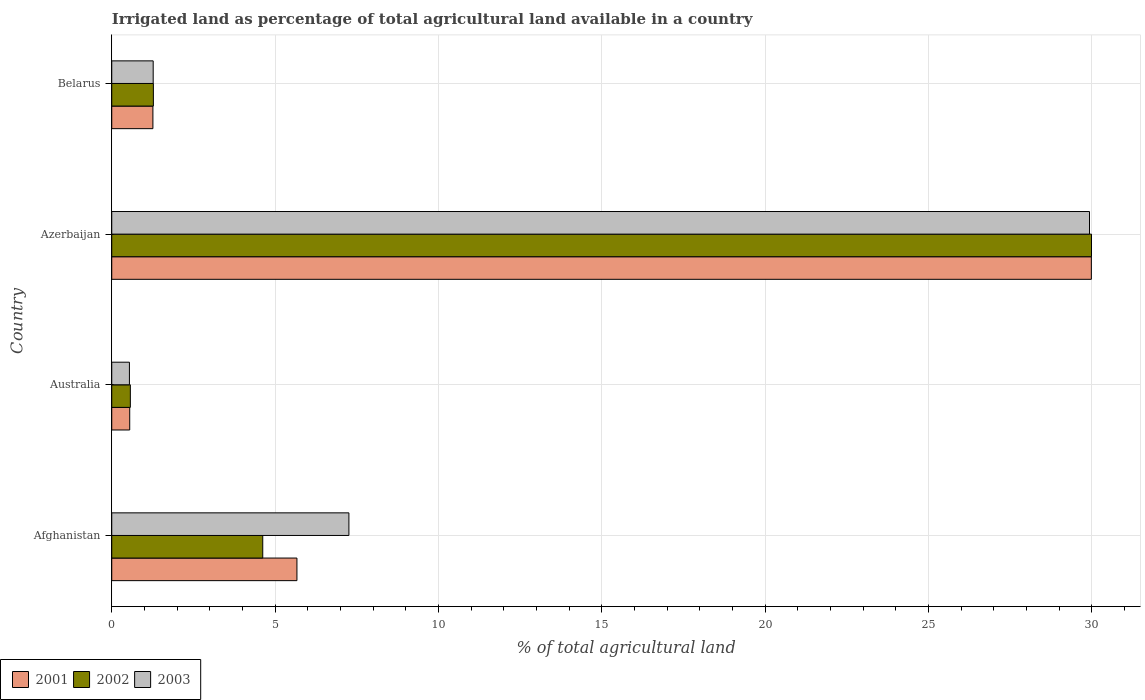How many bars are there on the 2nd tick from the bottom?
Provide a succinct answer. 3. What is the label of the 4th group of bars from the top?
Give a very brief answer. Afghanistan. In how many cases, is the number of bars for a given country not equal to the number of legend labels?
Your answer should be compact. 0. What is the percentage of irrigated land in 2001 in Azerbaijan?
Ensure brevity in your answer.  29.99. Across all countries, what is the maximum percentage of irrigated land in 2001?
Make the answer very short. 29.99. Across all countries, what is the minimum percentage of irrigated land in 2003?
Provide a short and direct response. 0.54. In which country was the percentage of irrigated land in 2003 maximum?
Provide a succinct answer. Azerbaijan. In which country was the percentage of irrigated land in 2003 minimum?
Your answer should be very brief. Australia. What is the total percentage of irrigated land in 2001 in the graph?
Make the answer very short. 37.46. What is the difference between the percentage of irrigated land in 2003 in Azerbaijan and that in Belarus?
Ensure brevity in your answer.  28.66. What is the difference between the percentage of irrigated land in 2003 in Afghanistan and the percentage of irrigated land in 2001 in Australia?
Keep it short and to the point. 6.71. What is the average percentage of irrigated land in 2001 per country?
Your answer should be very brief. 9.37. What is the difference between the percentage of irrigated land in 2001 and percentage of irrigated land in 2003 in Azerbaijan?
Your answer should be very brief. 0.06. In how many countries, is the percentage of irrigated land in 2002 greater than 2 %?
Offer a terse response. 2. What is the ratio of the percentage of irrigated land in 2002 in Australia to that in Azerbaijan?
Give a very brief answer. 0.02. Is the difference between the percentage of irrigated land in 2001 in Afghanistan and Australia greater than the difference between the percentage of irrigated land in 2003 in Afghanistan and Australia?
Your response must be concise. No. What is the difference between the highest and the second highest percentage of irrigated land in 2001?
Your response must be concise. 24.32. What is the difference between the highest and the lowest percentage of irrigated land in 2001?
Keep it short and to the point. 29.44. Is the sum of the percentage of irrigated land in 2002 in Azerbaijan and Belarus greater than the maximum percentage of irrigated land in 2003 across all countries?
Provide a short and direct response. Yes. What does the 3rd bar from the bottom in Australia represents?
Give a very brief answer. 2003. Are all the bars in the graph horizontal?
Offer a very short reply. Yes. What is the difference between two consecutive major ticks on the X-axis?
Offer a very short reply. 5. Are the values on the major ticks of X-axis written in scientific E-notation?
Keep it short and to the point. No. How many legend labels are there?
Offer a terse response. 3. How are the legend labels stacked?
Your response must be concise. Horizontal. What is the title of the graph?
Offer a very short reply. Irrigated land as percentage of total agricultural land available in a country. What is the label or title of the X-axis?
Your answer should be compact. % of total agricultural land. What is the % of total agricultural land of 2001 in Afghanistan?
Offer a very short reply. 5.67. What is the % of total agricultural land in 2002 in Afghanistan?
Provide a succinct answer. 4.62. What is the % of total agricultural land in 2003 in Afghanistan?
Offer a terse response. 7.26. What is the % of total agricultural land in 2001 in Australia?
Your response must be concise. 0.55. What is the % of total agricultural land of 2002 in Australia?
Provide a succinct answer. 0.57. What is the % of total agricultural land in 2003 in Australia?
Ensure brevity in your answer.  0.54. What is the % of total agricultural land of 2001 in Azerbaijan?
Offer a very short reply. 29.99. What is the % of total agricultural land in 2002 in Azerbaijan?
Offer a terse response. 29.99. What is the % of total agricultural land in 2003 in Azerbaijan?
Make the answer very short. 29.93. What is the % of total agricultural land of 2001 in Belarus?
Provide a succinct answer. 1.26. What is the % of total agricultural land in 2002 in Belarus?
Your response must be concise. 1.27. What is the % of total agricultural land of 2003 in Belarus?
Give a very brief answer. 1.27. Across all countries, what is the maximum % of total agricultural land of 2001?
Offer a terse response. 29.99. Across all countries, what is the maximum % of total agricultural land in 2002?
Your answer should be very brief. 29.99. Across all countries, what is the maximum % of total agricultural land in 2003?
Ensure brevity in your answer.  29.93. Across all countries, what is the minimum % of total agricultural land of 2001?
Give a very brief answer. 0.55. Across all countries, what is the minimum % of total agricultural land of 2002?
Give a very brief answer. 0.57. Across all countries, what is the minimum % of total agricultural land of 2003?
Your answer should be very brief. 0.54. What is the total % of total agricultural land of 2001 in the graph?
Give a very brief answer. 37.46. What is the total % of total agricultural land of 2002 in the graph?
Offer a terse response. 36.46. What is the total % of total agricultural land of 2003 in the graph?
Your response must be concise. 39. What is the difference between the % of total agricultural land of 2001 in Afghanistan and that in Australia?
Your answer should be compact. 5.12. What is the difference between the % of total agricultural land in 2002 in Afghanistan and that in Australia?
Give a very brief answer. 4.05. What is the difference between the % of total agricultural land in 2003 in Afghanistan and that in Australia?
Give a very brief answer. 6.72. What is the difference between the % of total agricultural land of 2001 in Afghanistan and that in Azerbaijan?
Keep it short and to the point. -24.32. What is the difference between the % of total agricultural land in 2002 in Afghanistan and that in Azerbaijan?
Offer a terse response. -25.37. What is the difference between the % of total agricultural land in 2003 in Afghanistan and that in Azerbaijan?
Provide a short and direct response. -22.67. What is the difference between the % of total agricultural land in 2001 in Afghanistan and that in Belarus?
Offer a very short reply. 4.41. What is the difference between the % of total agricultural land in 2002 in Afghanistan and that in Belarus?
Keep it short and to the point. 3.35. What is the difference between the % of total agricultural land of 2003 in Afghanistan and that in Belarus?
Keep it short and to the point. 5.99. What is the difference between the % of total agricultural land of 2001 in Australia and that in Azerbaijan?
Your answer should be very brief. -29.44. What is the difference between the % of total agricultural land in 2002 in Australia and that in Azerbaijan?
Make the answer very short. -29.42. What is the difference between the % of total agricultural land in 2003 in Australia and that in Azerbaijan?
Your answer should be compact. -29.39. What is the difference between the % of total agricultural land in 2001 in Australia and that in Belarus?
Provide a succinct answer. -0.71. What is the difference between the % of total agricultural land of 2002 in Australia and that in Belarus?
Keep it short and to the point. -0.7. What is the difference between the % of total agricultural land in 2003 in Australia and that in Belarus?
Keep it short and to the point. -0.73. What is the difference between the % of total agricultural land of 2001 in Azerbaijan and that in Belarus?
Make the answer very short. 28.73. What is the difference between the % of total agricultural land of 2002 in Azerbaijan and that in Belarus?
Offer a terse response. 28.72. What is the difference between the % of total agricultural land in 2003 in Azerbaijan and that in Belarus?
Offer a terse response. 28.66. What is the difference between the % of total agricultural land of 2001 in Afghanistan and the % of total agricultural land of 2002 in Australia?
Keep it short and to the point. 5.1. What is the difference between the % of total agricultural land in 2001 in Afghanistan and the % of total agricultural land in 2003 in Australia?
Give a very brief answer. 5.13. What is the difference between the % of total agricultural land of 2002 in Afghanistan and the % of total agricultural land of 2003 in Australia?
Provide a short and direct response. 4.08. What is the difference between the % of total agricultural land in 2001 in Afghanistan and the % of total agricultural land in 2002 in Azerbaijan?
Offer a very short reply. -24.32. What is the difference between the % of total agricultural land of 2001 in Afghanistan and the % of total agricultural land of 2003 in Azerbaijan?
Your response must be concise. -24.26. What is the difference between the % of total agricultural land in 2002 in Afghanistan and the % of total agricultural land in 2003 in Azerbaijan?
Your response must be concise. -25.31. What is the difference between the % of total agricultural land of 2001 in Afghanistan and the % of total agricultural land of 2002 in Belarus?
Keep it short and to the point. 4.39. What is the difference between the % of total agricultural land of 2001 in Afghanistan and the % of total agricultural land of 2003 in Belarus?
Offer a terse response. 4.4. What is the difference between the % of total agricultural land in 2002 in Afghanistan and the % of total agricultural land in 2003 in Belarus?
Keep it short and to the point. 3.35. What is the difference between the % of total agricultural land in 2001 in Australia and the % of total agricultural land in 2002 in Azerbaijan?
Provide a succinct answer. -29.44. What is the difference between the % of total agricultural land in 2001 in Australia and the % of total agricultural land in 2003 in Azerbaijan?
Offer a terse response. -29.38. What is the difference between the % of total agricultural land of 2002 in Australia and the % of total agricultural land of 2003 in Azerbaijan?
Keep it short and to the point. -29.36. What is the difference between the % of total agricultural land of 2001 in Australia and the % of total agricultural land of 2002 in Belarus?
Your answer should be compact. -0.72. What is the difference between the % of total agricultural land of 2001 in Australia and the % of total agricultural land of 2003 in Belarus?
Offer a very short reply. -0.72. What is the difference between the % of total agricultural land of 2002 in Australia and the % of total agricultural land of 2003 in Belarus?
Your response must be concise. -0.7. What is the difference between the % of total agricultural land in 2001 in Azerbaijan and the % of total agricultural land in 2002 in Belarus?
Your response must be concise. 28.71. What is the difference between the % of total agricultural land of 2001 in Azerbaijan and the % of total agricultural land of 2003 in Belarus?
Provide a succinct answer. 28.72. What is the difference between the % of total agricultural land of 2002 in Azerbaijan and the % of total agricultural land of 2003 in Belarus?
Your answer should be compact. 28.72. What is the average % of total agricultural land of 2001 per country?
Offer a terse response. 9.37. What is the average % of total agricultural land in 2002 per country?
Provide a succinct answer. 9.11. What is the average % of total agricultural land in 2003 per country?
Your answer should be compact. 9.75. What is the difference between the % of total agricultural land in 2001 and % of total agricultural land in 2002 in Afghanistan?
Your response must be concise. 1.05. What is the difference between the % of total agricultural land of 2001 and % of total agricultural land of 2003 in Afghanistan?
Keep it short and to the point. -1.59. What is the difference between the % of total agricultural land in 2002 and % of total agricultural land in 2003 in Afghanistan?
Your answer should be compact. -2.64. What is the difference between the % of total agricultural land in 2001 and % of total agricultural land in 2002 in Australia?
Ensure brevity in your answer.  -0.02. What is the difference between the % of total agricultural land in 2001 and % of total agricultural land in 2003 in Australia?
Offer a terse response. 0.01. What is the difference between the % of total agricultural land of 2002 and % of total agricultural land of 2003 in Australia?
Your answer should be very brief. 0.03. What is the difference between the % of total agricultural land of 2001 and % of total agricultural land of 2002 in Azerbaijan?
Give a very brief answer. -0. What is the difference between the % of total agricultural land in 2001 and % of total agricultural land in 2003 in Azerbaijan?
Keep it short and to the point. 0.06. What is the difference between the % of total agricultural land in 2002 and % of total agricultural land in 2003 in Azerbaijan?
Give a very brief answer. 0.06. What is the difference between the % of total agricultural land in 2001 and % of total agricultural land in 2002 in Belarus?
Offer a terse response. -0.01. What is the difference between the % of total agricultural land in 2001 and % of total agricultural land in 2003 in Belarus?
Offer a very short reply. -0.01. What is the difference between the % of total agricultural land of 2002 and % of total agricultural land of 2003 in Belarus?
Your answer should be compact. 0.01. What is the ratio of the % of total agricultural land in 2001 in Afghanistan to that in Australia?
Your answer should be compact. 10.31. What is the ratio of the % of total agricultural land of 2002 in Afghanistan to that in Australia?
Your answer should be compact. 8.12. What is the ratio of the % of total agricultural land in 2003 in Afghanistan to that in Australia?
Your answer should be compact. 13.42. What is the ratio of the % of total agricultural land in 2001 in Afghanistan to that in Azerbaijan?
Ensure brevity in your answer.  0.19. What is the ratio of the % of total agricultural land of 2002 in Afghanistan to that in Azerbaijan?
Give a very brief answer. 0.15. What is the ratio of the % of total agricultural land in 2003 in Afghanistan to that in Azerbaijan?
Your response must be concise. 0.24. What is the ratio of the % of total agricultural land in 2001 in Afghanistan to that in Belarus?
Your answer should be compact. 4.5. What is the ratio of the % of total agricultural land of 2002 in Afghanistan to that in Belarus?
Your answer should be compact. 3.63. What is the ratio of the % of total agricultural land of 2003 in Afghanistan to that in Belarus?
Provide a succinct answer. 5.72. What is the ratio of the % of total agricultural land of 2001 in Australia to that in Azerbaijan?
Offer a very short reply. 0.02. What is the ratio of the % of total agricultural land of 2002 in Australia to that in Azerbaijan?
Your answer should be very brief. 0.02. What is the ratio of the % of total agricultural land of 2003 in Australia to that in Azerbaijan?
Your answer should be compact. 0.02. What is the ratio of the % of total agricultural land of 2001 in Australia to that in Belarus?
Offer a very short reply. 0.44. What is the ratio of the % of total agricultural land of 2002 in Australia to that in Belarus?
Make the answer very short. 0.45. What is the ratio of the % of total agricultural land of 2003 in Australia to that in Belarus?
Offer a very short reply. 0.43. What is the ratio of the % of total agricultural land of 2001 in Azerbaijan to that in Belarus?
Ensure brevity in your answer.  23.8. What is the ratio of the % of total agricultural land in 2002 in Azerbaijan to that in Belarus?
Offer a very short reply. 23.54. What is the ratio of the % of total agricultural land in 2003 in Azerbaijan to that in Belarus?
Keep it short and to the point. 23.59. What is the difference between the highest and the second highest % of total agricultural land in 2001?
Your answer should be compact. 24.32. What is the difference between the highest and the second highest % of total agricultural land of 2002?
Your response must be concise. 25.37. What is the difference between the highest and the second highest % of total agricultural land in 2003?
Your response must be concise. 22.67. What is the difference between the highest and the lowest % of total agricultural land of 2001?
Provide a short and direct response. 29.44. What is the difference between the highest and the lowest % of total agricultural land of 2002?
Provide a succinct answer. 29.42. What is the difference between the highest and the lowest % of total agricultural land in 2003?
Make the answer very short. 29.39. 